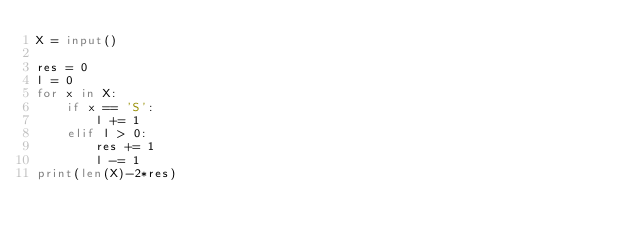<code> <loc_0><loc_0><loc_500><loc_500><_Python_>X = input()

res = 0
l = 0
for x in X:
    if x == 'S':
        l += 1
    elif l > 0:
        res += 1
        l -= 1
print(len(X)-2*res)</code> 